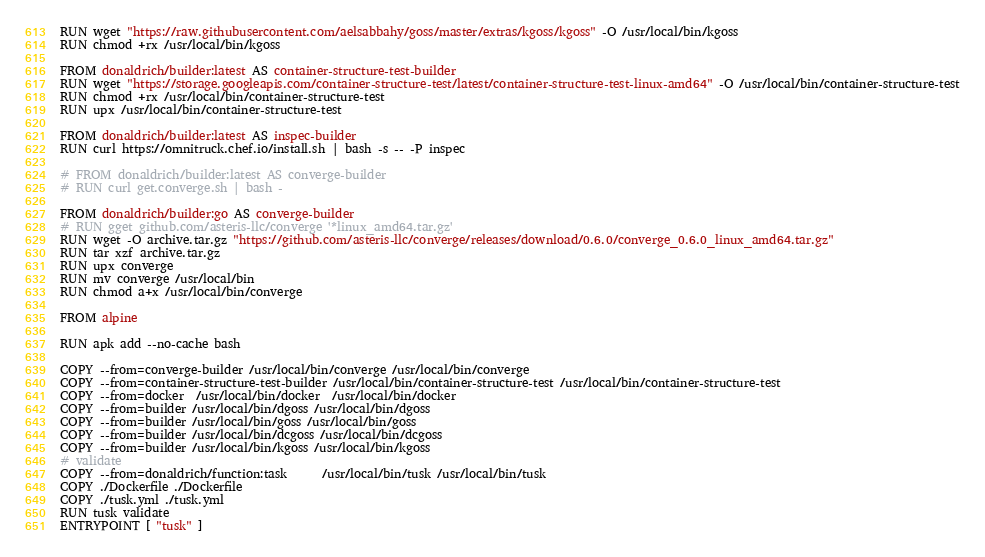<code> <loc_0><loc_0><loc_500><loc_500><_Dockerfile_>
RUN wget "https://raw.githubusercontent.com/aelsabbahy/goss/master/extras/kgoss/kgoss" -O /usr/local/bin/kgoss
RUN chmod +rx /usr/local/bin/kgoss

FROM donaldrich/builder:latest AS container-structure-test-builder
RUN wget "https://storage.googleapis.com/container-structure-test/latest/container-structure-test-linux-amd64" -O /usr/local/bin/container-structure-test
RUN chmod +rx /usr/local/bin/container-structure-test
RUN upx /usr/local/bin/container-structure-test

FROM donaldrich/builder:latest AS inspec-builder
RUN curl https://omnitruck.chef.io/install.sh | bash -s -- -P inspec

# FROM donaldrich/builder:latest AS converge-builder
# RUN curl get.converge.sh | bash -

FROM donaldrich/builder:go AS converge-builder
# RUN gget github.com/asteris-llc/converge '*linux_amd64.tar.gz'
RUN wget -O archive.tar.gz "https://github.com/asteris-llc/converge/releases/download/0.6.0/converge_0.6.0_linux_amd64.tar.gz"
RUN tar xzf archive.tar.gz
RUN upx converge
RUN mv converge /usr/local/bin
RUN chmod a+x /usr/local/bin/converge

FROM alpine

RUN apk add --no-cache bash

COPY --from=converge-builder /usr/local/bin/converge /usr/local/bin/converge
COPY --from=container-structure-test-builder /usr/local/bin/container-structure-test /usr/local/bin/container-structure-test
COPY --from=docker  /usr/local/bin/docker  /usr/local/bin/docker
COPY --from=builder /usr/local/bin/dgoss /usr/local/bin/dgoss
COPY --from=builder /usr/local/bin/goss /usr/local/bin/goss
COPY --from=builder /usr/local/bin/dcgoss /usr/local/bin/dcgoss
COPY --from=builder /usr/local/bin/kgoss /usr/local/bin/kgoss
# validate
COPY --from=donaldrich/function:task      /usr/local/bin/tusk /usr/local/bin/tusk
COPY ./Dockerfile ./Dockerfile
COPY ./tusk.yml ./tusk.yml
RUN tusk validate
ENTRYPOINT [ "tusk" ]
</code> 